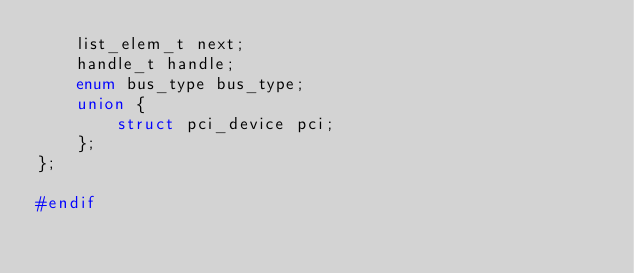<code> <loc_0><loc_0><loc_500><loc_500><_C_>    list_elem_t next;
    handle_t handle;
    enum bus_type bus_type;
    union {
        struct pci_device pci;
    };
};

#endif
</code> 